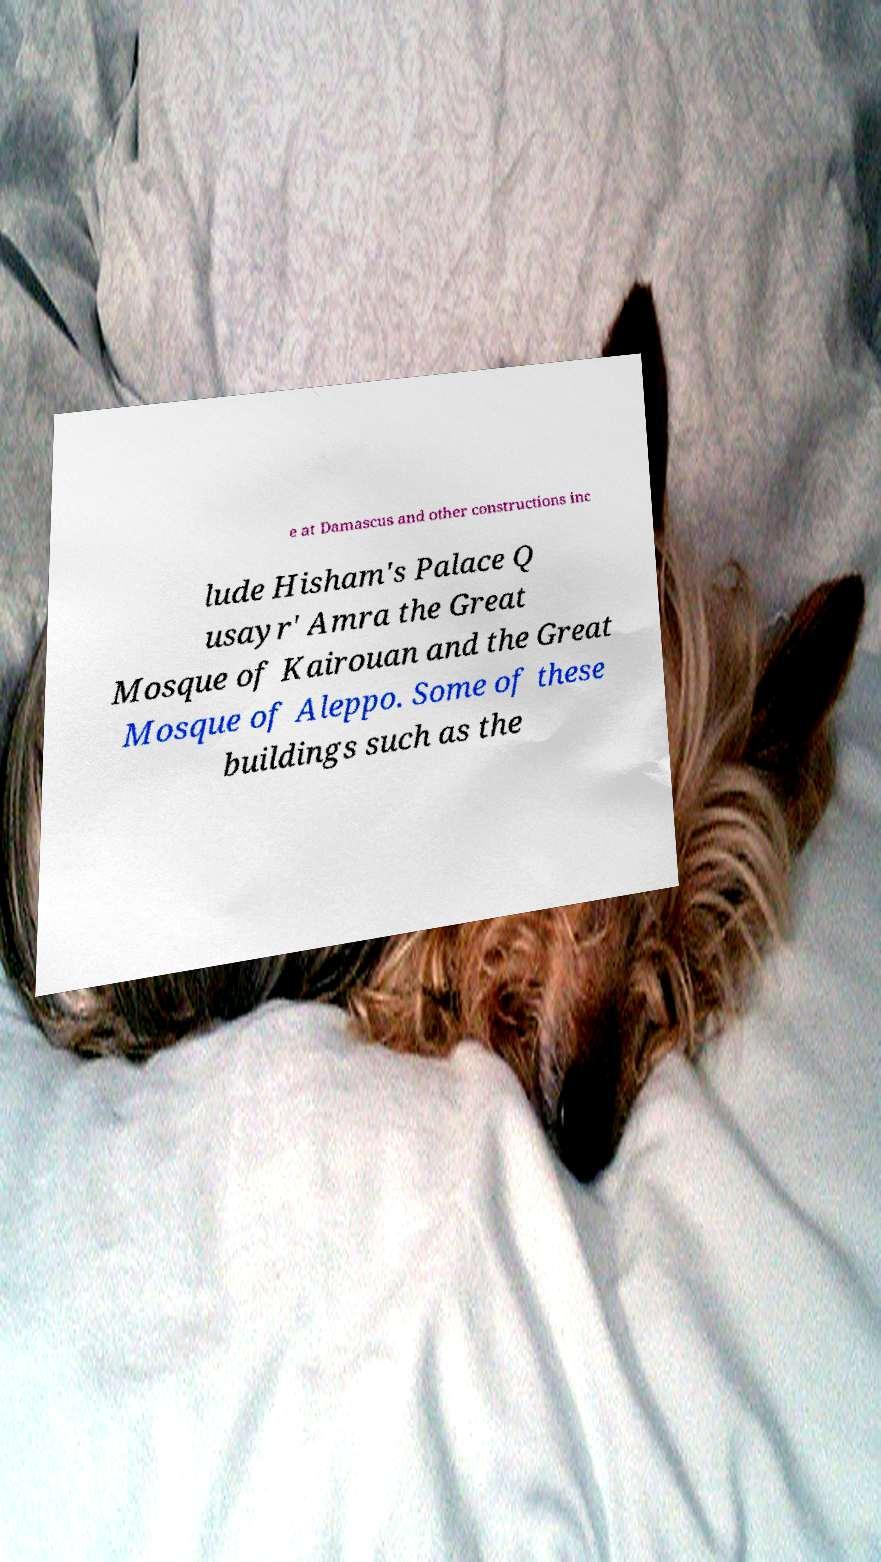Please read and relay the text visible in this image. What does it say? e at Damascus and other constructions inc lude Hisham's Palace Q usayr' Amra the Great Mosque of Kairouan and the Great Mosque of Aleppo. Some of these buildings such as the 